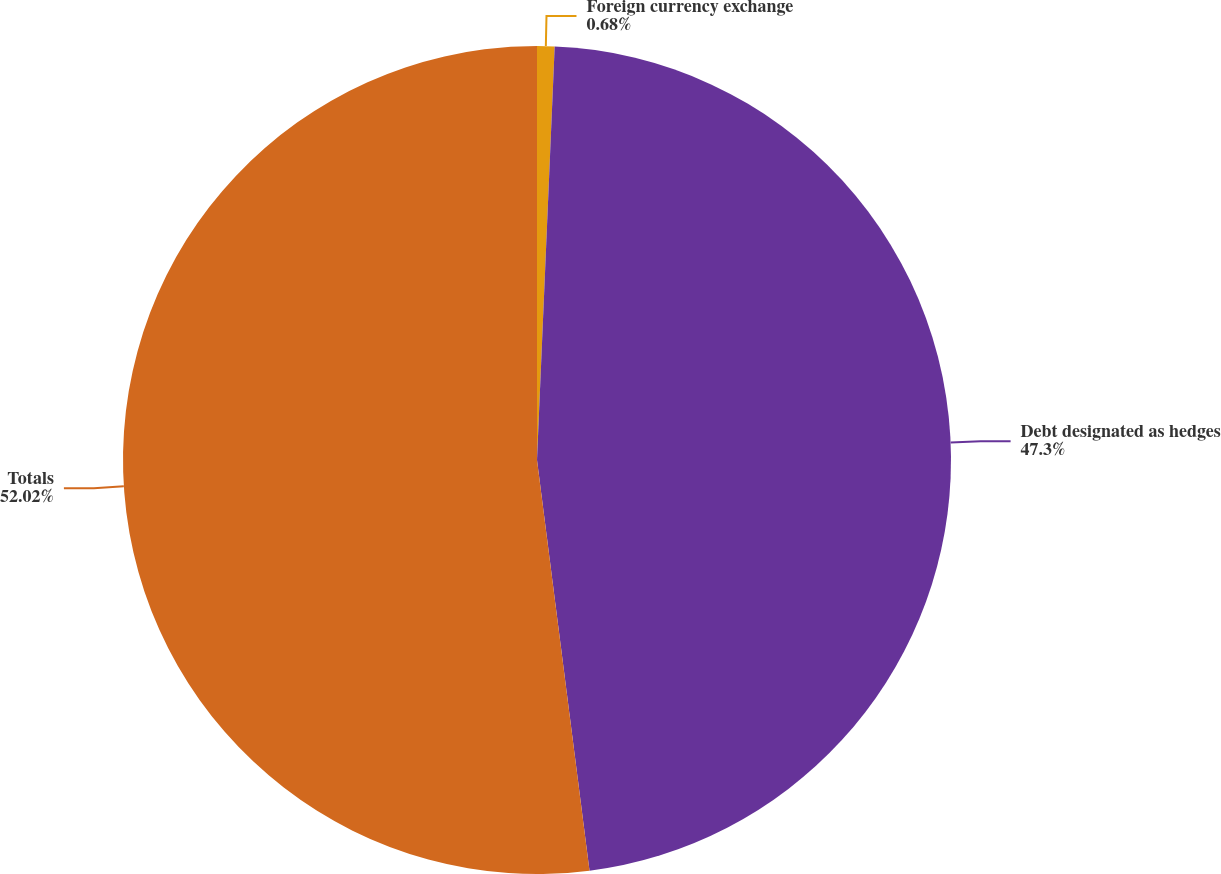Convert chart. <chart><loc_0><loc_0><loc_500><loc_500><pie_chart><fcel>Foreign currency exchange<fcel>Debt designated as hedges<fcel>Totals<nl><fcel>0.68%<fcel>47.3%<fcel>52.03%<nl></chart> 